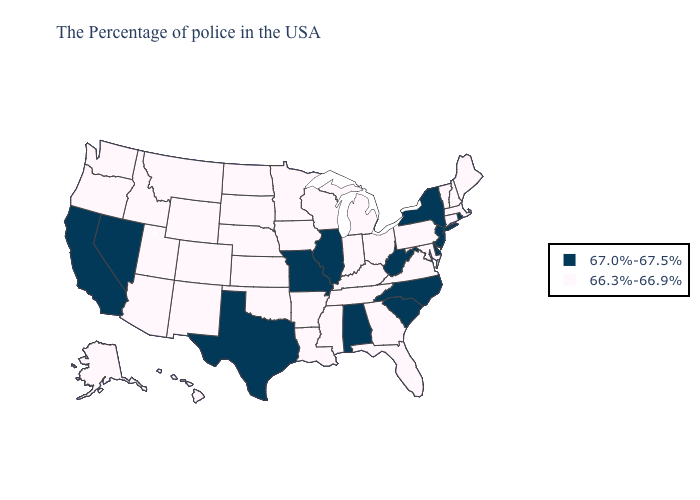Does the first symbol in the legend represent the smallest category?
Give a very brief answer. No. Name the states that have a value in the range 66.3%-66.9%?
Short answer required. Maine, Massachusetts, New Hampshire, Vermont, Connecticut, Maryland, Pennsylvania, Virginia, Ohio, Florida, Georgia, Michigan, Kentucky, Indiana, Tennessee, Wisconsin, Mississippi, Louisiana, Arkansas, Minnesota, Iowa, Kansas, Nebraska, Oklahoma, South Dakota, North Dakota, Wyoming, Colorado, New Mexico, Utah, Montana, Arizona, Idaho, Washington, Oregon, Alaska, Hawaii. Does the first symbol in the legend represent the smallest category?
Give a very brief answer. No. Does North Carolina have the lowest value in the South?
Write a very short answer. No. What is the lowest value in states that border Iowa?
Short answer required. 66.3%-66.9%. Name the states that have a value in the range 66.3%-66.9%?
Be succinct. Maine, Massachusetts, New Hampshire, Vermont, Connecticut, Maryland, Pennsylvania, Virginia, Ohio, Florida, Georgia, Michigan, Kentucky, Indiana, Tennessee, Wisconsin, Mississippi, Louisiana, Arkansas, Minnesota, Iowa, Kansas, Nebraska, Oklahoma, South Dakota, North Dakota, Wyoming, Colorado, New Mexico, Utah, Montana, Arizona, Idaho, Washington, Oregon, Alaska, Hawaii. Name the states that have a value in the range 67.0%-67.5%?
Keep it brief. Rhode Island, New York, New Jersey, Delaware, North Carolina, South Carolina, West Virginia, Alabama, Illinois, Missouri, Texas, Nevada, California. Name the states that have a value in the range 67.0%-67.5%?
Be succinct. Rhode Island, New York, New Jersey, Delaware, North Carolina, South Carolina, West Virginia, Alabama, Illinois, Missouri, Texas, Nevada, California. Does the first symbol in the legend represent the smallest category?
Answer briefly. No. Does Wyoming have the lowest value in the USA?
Be succinct. Yes. Among the states that border Tennessee , which have the highest value?
Be succinct. North Carolina, Alabama, Missouri. Which states hav the highest value in the West?
Keep it brief. Nevada, California. Does Alabama have a lower value than New Hampshire?
Short answer required. No. Does South Carolina have a lower value than Nebraska?
Give a very brief answer. No. 